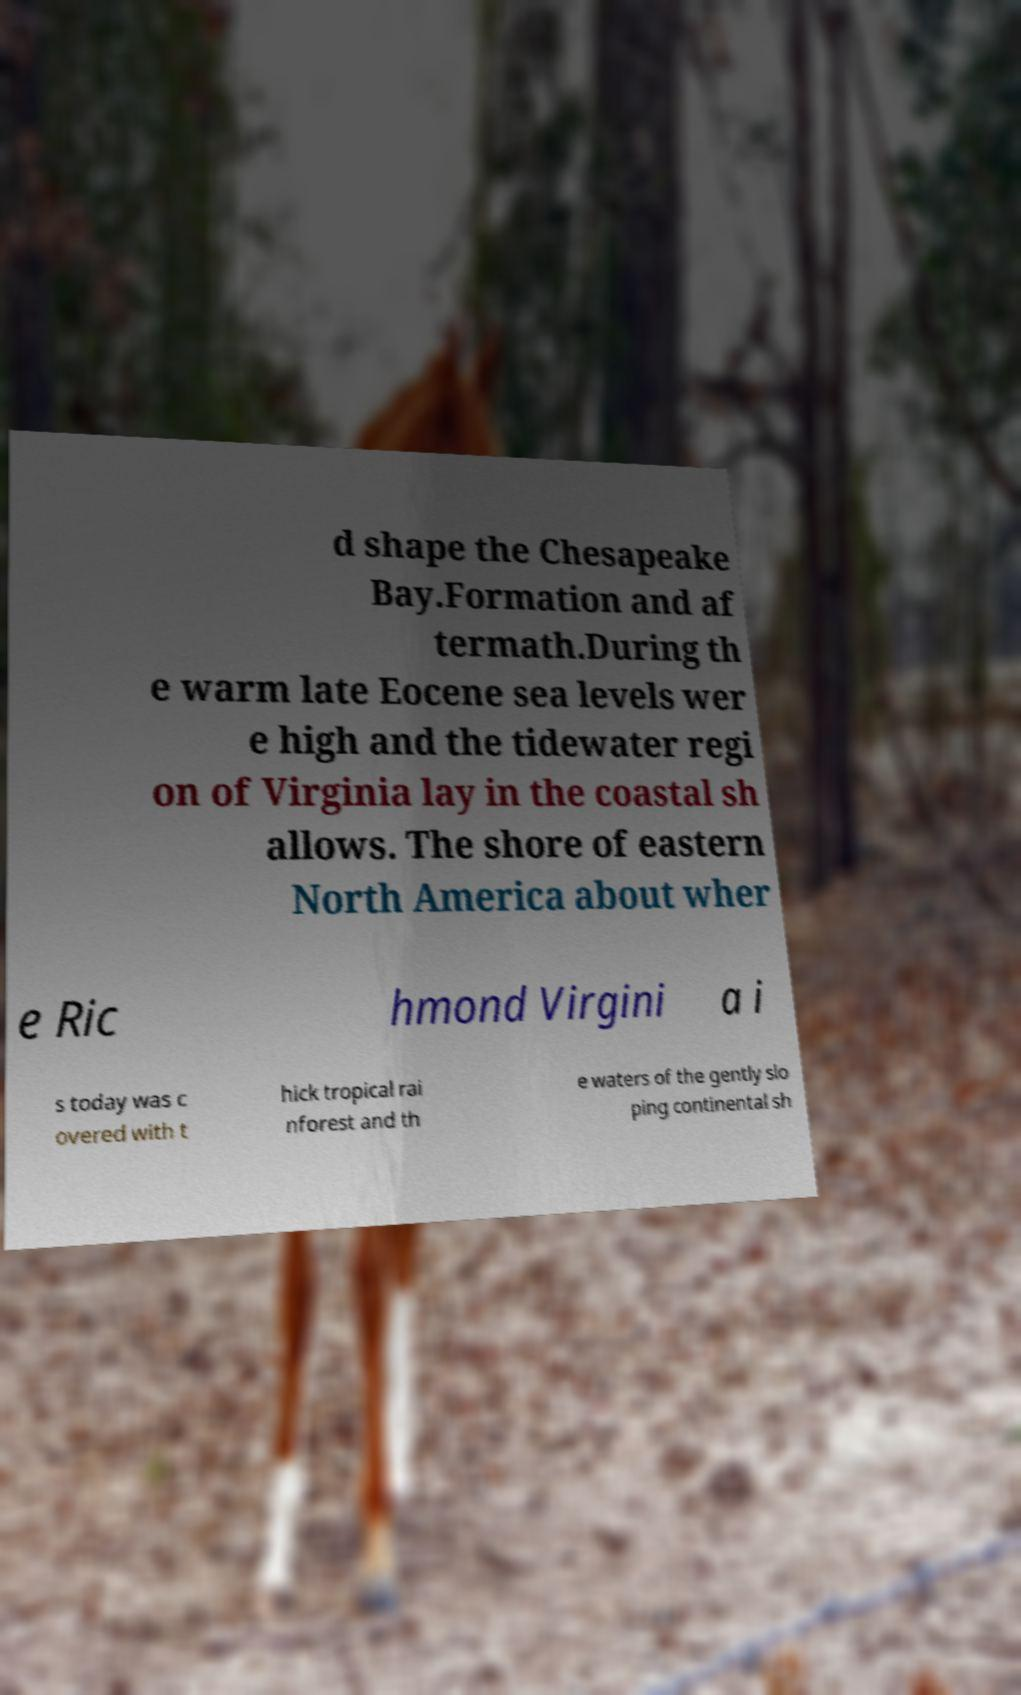Please identify and transcribe the text found in this image. d shape the Chesapeake Bay.Formation and af termath.During th e warm late Eocene sea levels wer e high and the tidewater regi on of Virginia lay in the coastal sh allows. The shore of eastern North America about wher e Ric hmond Virgini a i s today was c overed with t hick tropical rai nforest and th e waters of the gently slo ping continental sh 